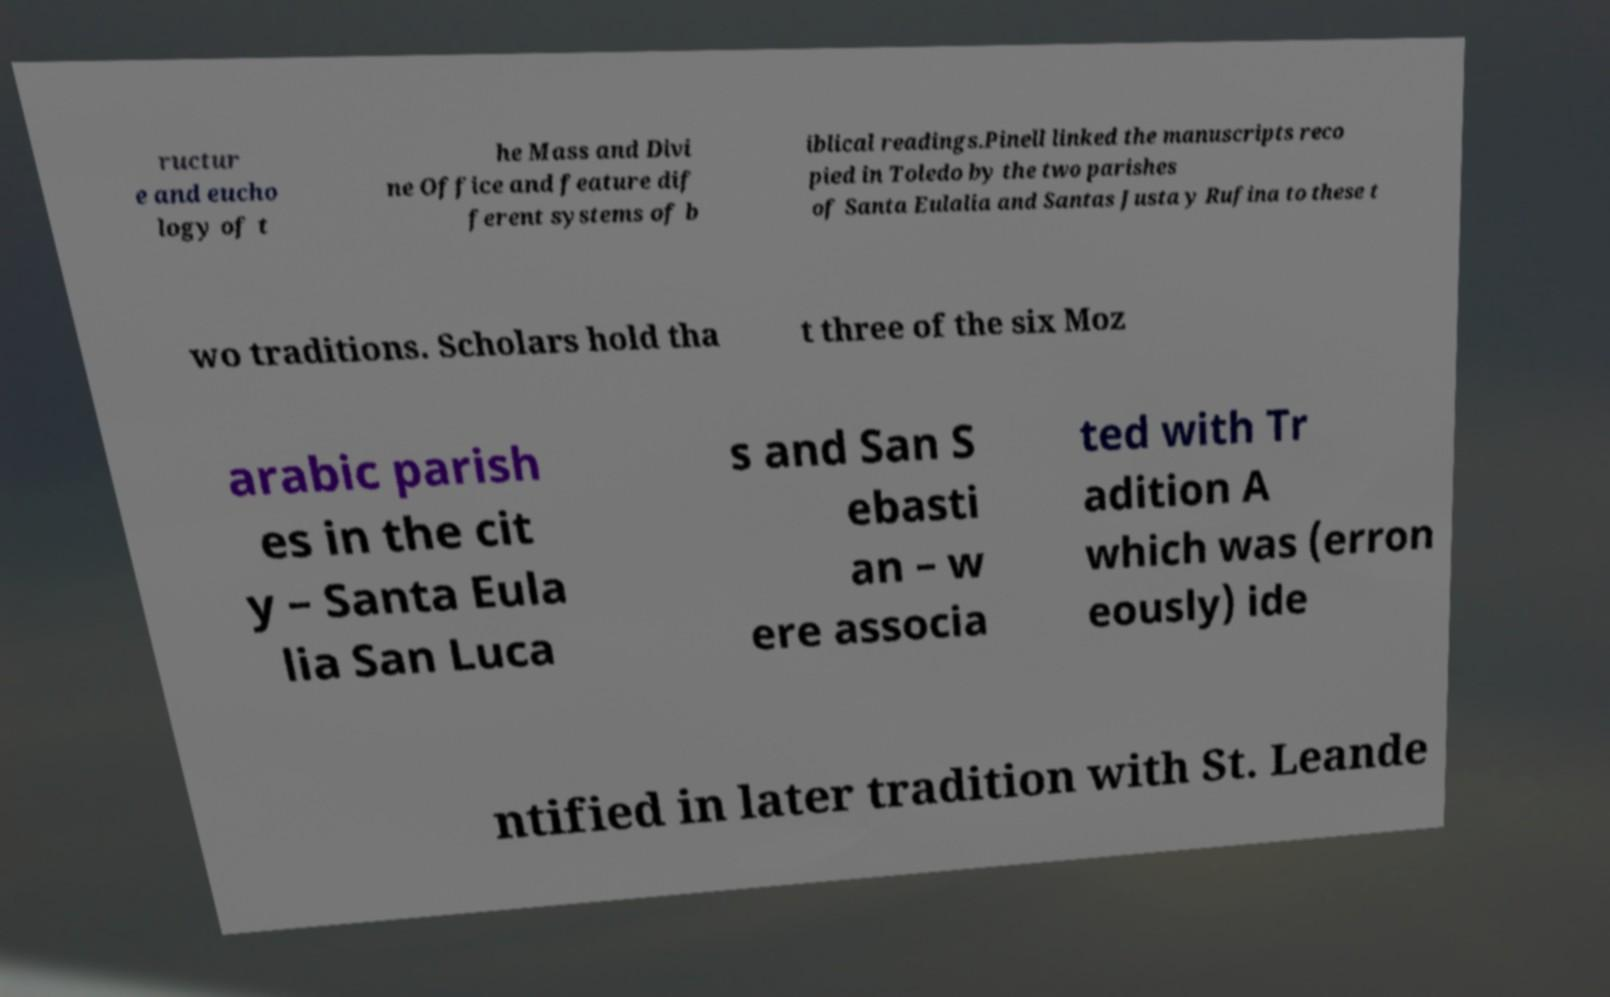I need the written content from this picture converted into text. Can you do that? ructur e and eucho logy of t he Mass and Divi ne Office and feature dif ferent systems of b iblical readings.Pinell linked the manuscripts reco pied in Toledo by the two parishes of Santa Eulalia and Santas Justa y Rufina to these t wo traditions. Scholars hold tha t three of the six Moz arabic parish es in the cit y – Santa Eula lia San Luca s and San S ebasti an – w ere associa ted with Tr adition A which was (erron eously) ide ntified in later tradition with St. Leande 